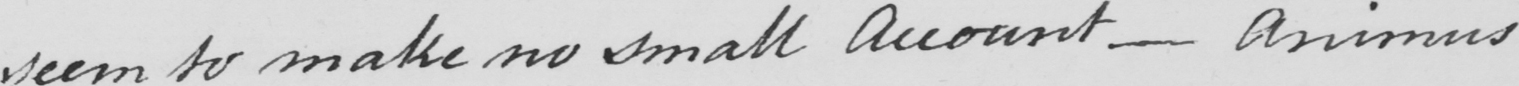What does this handwritten line say? seem to make no small account _  animus 